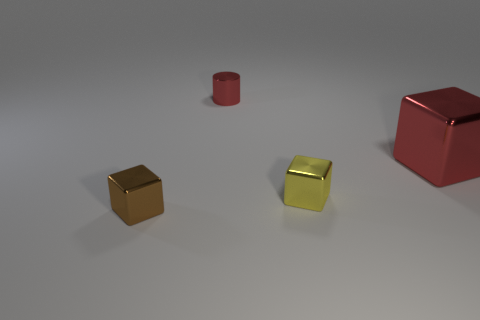Is the color of the large object the same as the small thing that is behind the yellow block?
Provide a succinct answer. Yes. How many things are left of the red metallic cylinder?
Offer a terse response. 1. What is the shape of the tiny thing on the right side of the red thing that is behind the big metallic cube?
Give a very brief answer. Cube. Are there any other things that are the same shape as the small red shiny object?
Offer a terse response. No. Are there more metallic things in front of the big thing than green rubber cubes?
Your answer should be compact. Yes. There is a red shiny object left of the large shiny block; how many things are left of it?
Make the answer very short. 1. There is a tiny brown metal object on the left side of the small shiny object behind the small block that is right of the tiny brown block; what shape is it?
Give a very brief answer. Cube. What is the size of the red metal cylinder?
Make the answer very short. Small. Is there a yellow block made of the same material as the cylinder?
Offer a terse response. Yes. The red object that is the same shape as the yellow thing is what size?
Keep it short and to the point. Large. 